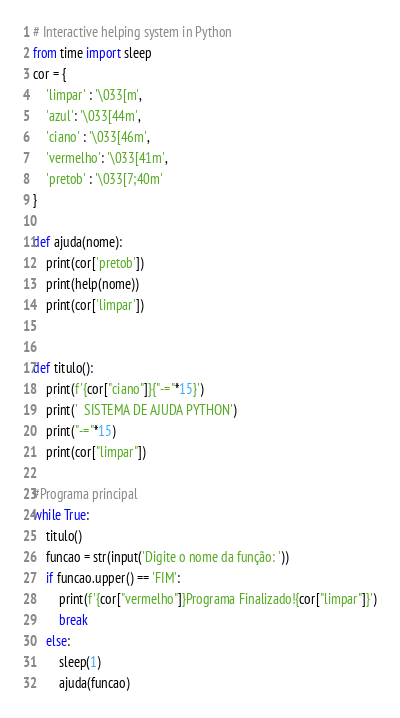Convert code to text. <code><loc_0><loc_0><loc_500><loc_500><_Python_># Interactive helping system in Python
from time import sleep
cor = {
    'limpar' : '\033[m',
    'azul': '\033[44m',
    'ciano' : '\033[46m',
    'vermelho': '\033[41m',
    'pretob' : '\033[7;40m'
}

def ajuda(nome):
    print(cor['pretob'])
    print(help(nome))
    print(cor['limpar'])


def titulo():
    print(f'{cor["ciano"]}{"-="*15}')
    print('  SISTEMA DE AJUDA PYTHON')
    print("-="*15)
    print(cor["limpar"])

#Programa principal
while True:
    titulo()
    funcao = str(input('Digite o nome da função: '))
    if funcao.upper() == 'FIM':
        print(f'{cor["vermelho"]}Programa Finalizado!{cor["limpar"]}')
        break
    else:
        sleep(1)
        ajuda(funcao)
</code> 